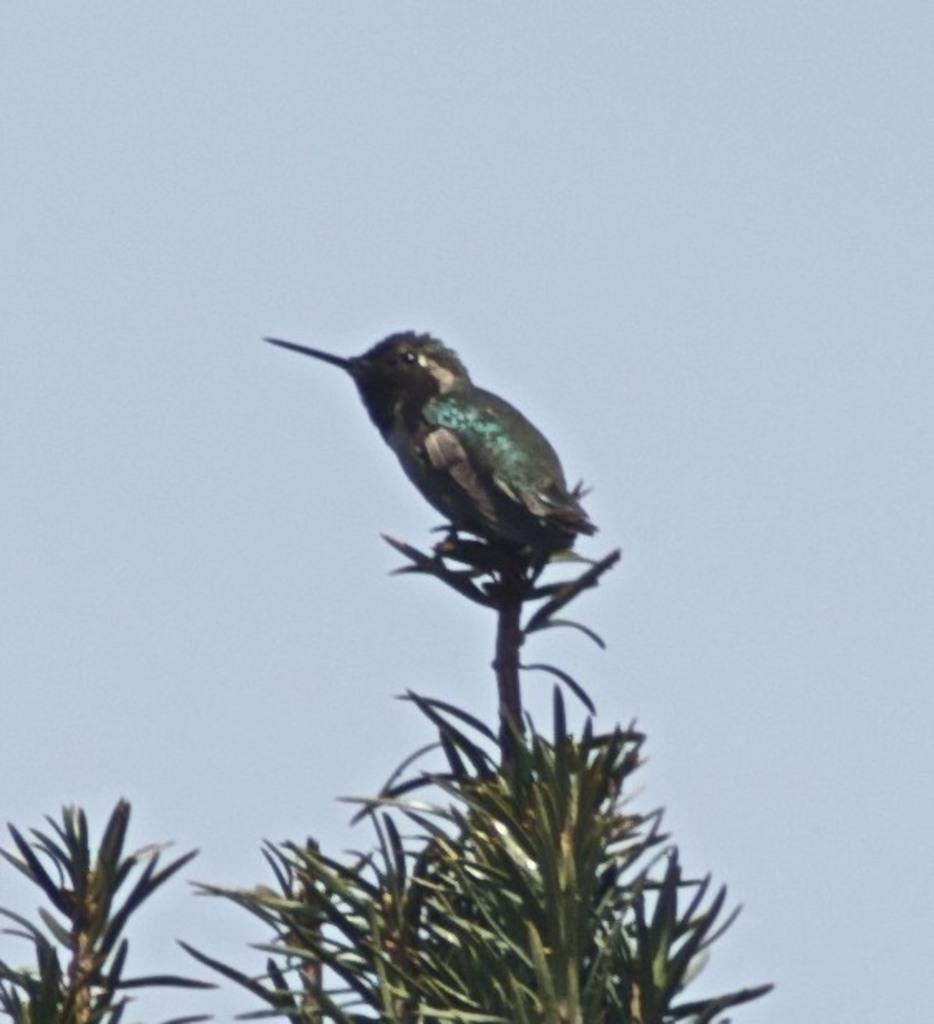What type of animal is in the image? There is a bird in the image. Where is the bird located? The bird is sitting on a plant. What can be seen in the background of the image? The sky is visible in the image. Can you determine the time of day the image was taken? The image was likely taken during the day, as the sky is visible and there is no indication of darkness. What type of rhythm does the bird have in the image? The bird does not have a rhythm in the image, as it is a still photograph. Is the bird's print visible in the image? There is no mention of a bird's print in the provided facts, and it is not visible in the image. 